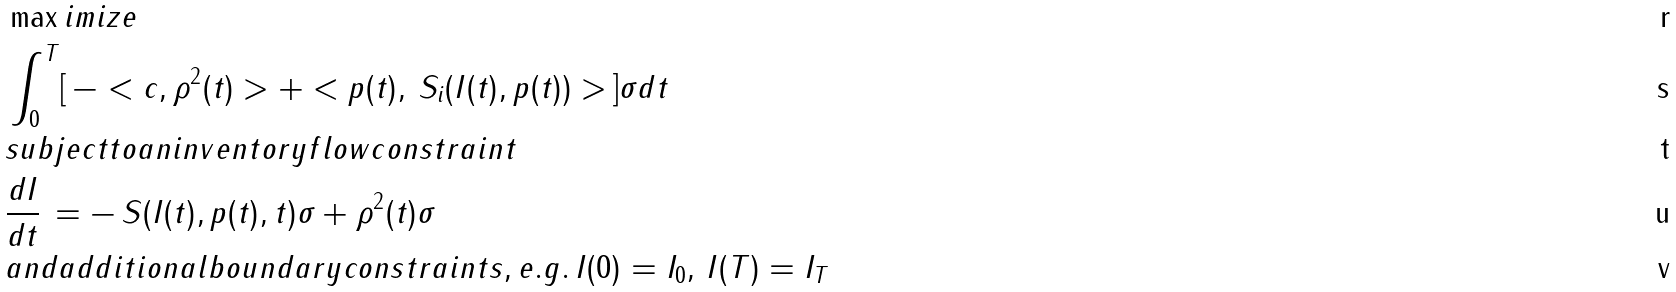Convert formula to latex. <formula><loc_0><loc_0><loc_500><loc_500>& \max i m i z e \\ & \int _ { 0 } ^ { T } [ \, - < c , \rho ^ { 2 } ( t ) > + < p ( t ) , \, S _ { i } ( I ( t ) , p ( t ) ) > \, ] \sigma d t \\ & s u b j e c t t o a n i n v e n t o r y f l o w c o n s t r a i n t \\ & \frac { d I } { d t } \, = - \, S ( I ( t ) , p ( t ) , t ) \sigma + \rho ^ { 2 } ( t ) \sigma \\ & a n d a d d i t i o n a l b o u n d a r y c o n s t r a i n t s , e . g . \, I ( 0 ) = I _ { 0 } , \, I ( T ) = I _ { T }</formula> 